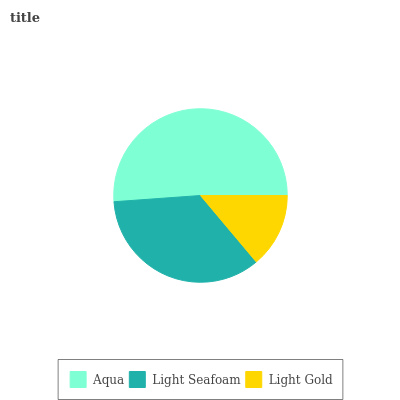Is Light Gold the minimum?
Answer yes or no. Yes. Is Aqua the maximum?
Answer yes or no. Yes. Is Light Seafoam the minimum?
Answer yes or no. No. Is Light Seafoam the maximum?
Answer yes or no. No. Is Aqua greater than Light Seafoam?
Answer yes or no. Yes. Is Light Seafoam less than Aqua?
Answer yes or no. Yes. Is Light Seafoam greater than Aqua?
Answer yes or no. No. Is Aqua less than Light Seafoam?
Answer yes or no. No. Is Light Seafoam the high median?
Answer yes or no. Yes. Is Light Seafoam the low median?
Answer yes or no. Yes. Is Light Gold the high median?
Answer yes or no. No. Is Aqua the low median?
Answer yes or no. No. 